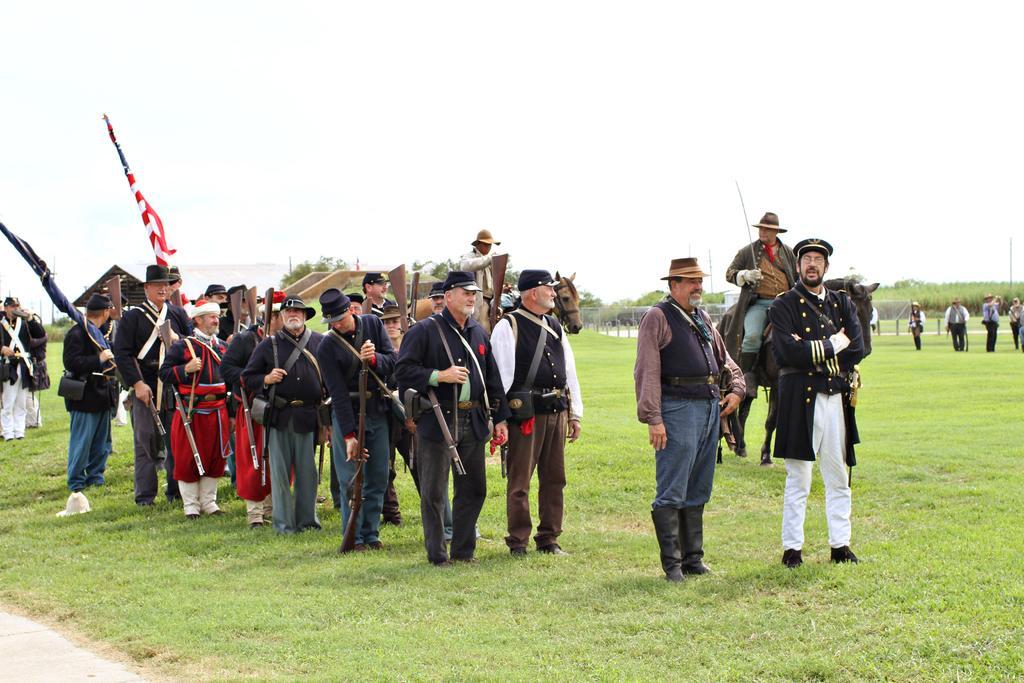Describe this image in one or two sentences. In this image, we can see a few people. We can see the ground covered with grass. We can see some horses. We can see some flags, poles. We can see some plants, trees. We can see a shed. We can also see the sky. 